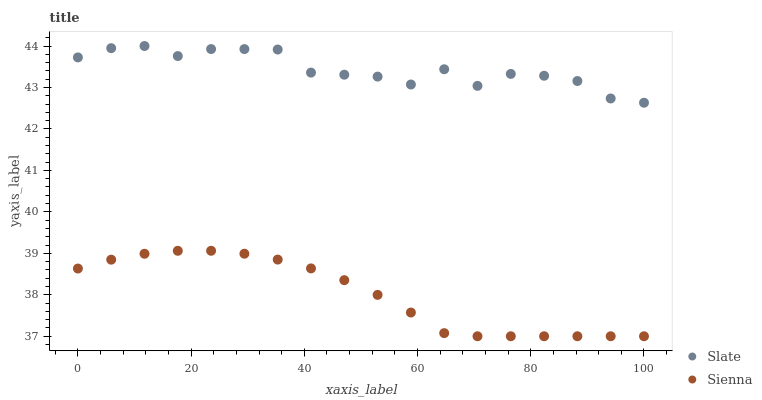Does Sienna have the minimum area under the curve?
Answer yes or no. Yes. Does Slate have the maximum area under the curve?
Answer yes or no. Yes. Does Slate have the minimum area under the curve?
Answer yes or no. No. Is Sienna the smoothest?
Answer yes or no. Yes. Is Slate the roughest?
Answer yes or no. Yes. Is Slate the smoothest?
Answer yes or no. No. Does Sienna have the lowest value?
Answer yes or no. Yes. Does Slate have the lowest value?
Answer yes or no. No. Does Slate have the highest value?
Answer yes or no. Yes. Is Sienna less than Slate?
Answer yes or no. Yes. Is Slate greater than Sienna?
Answer yes or no. Yes. Does Sienna intersect Slate?
Answer yes or no. No. 